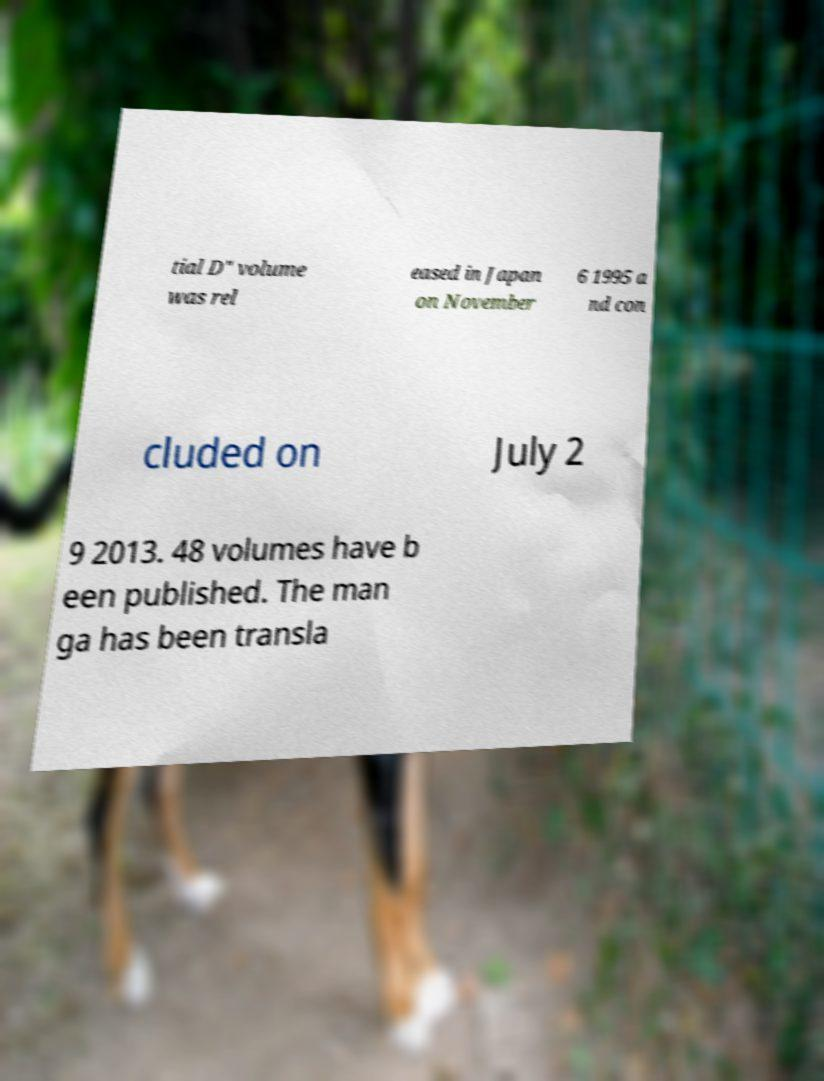What messages or text are displayed in this image? I need them in a readable, typed format. tial D" volume was rel eased in Japan on November 6 1995 a nd con cluded on July 2 9 2013. 48 volumes have b een published. The man ga has been transla 